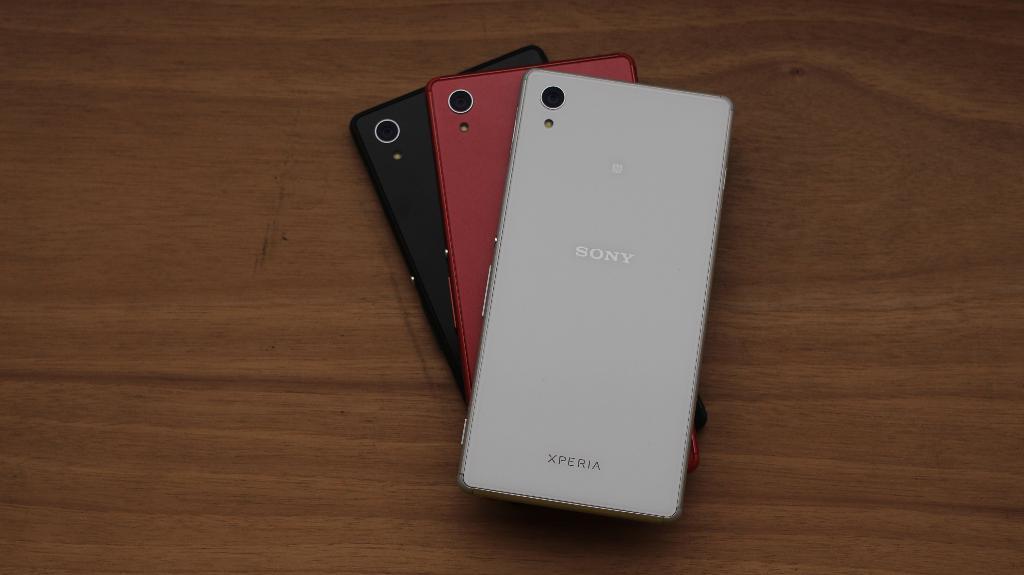What brand of phone is pictured here?
Ensure brevity in your answer.  Sony. 